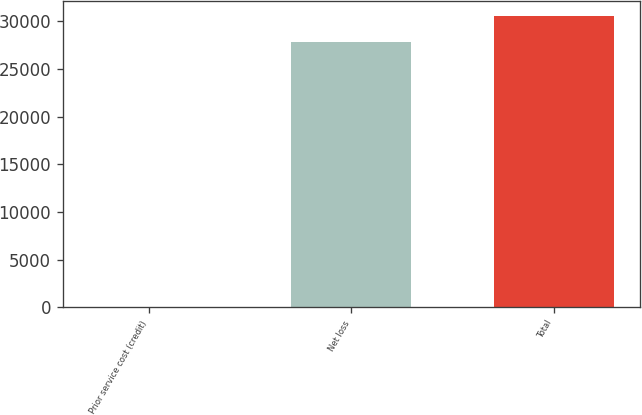Convert chart to OTSL. <chart><loc_0><loc_0><loc_500><loc_500><bar_chart><fcel>Prior service cost (credit)<fcel>Net loss<fcel>Total<nl><fcel>86<fcel>27789<fcel>30567.9<nl></chart> 